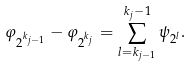Convert formula to latex. <formula><loc_0><loc_0><loc_500><loc_500>\varphi _ { 2 ^ { k _ { j - 1 } } } - \varphi _ { 2 ^ { k _ { j } } } = \sum _ { l = k _ { j - 1 } } ^ { k _ { j } - 1 } \psi _ { 2 ^ { l } } .</formula> 